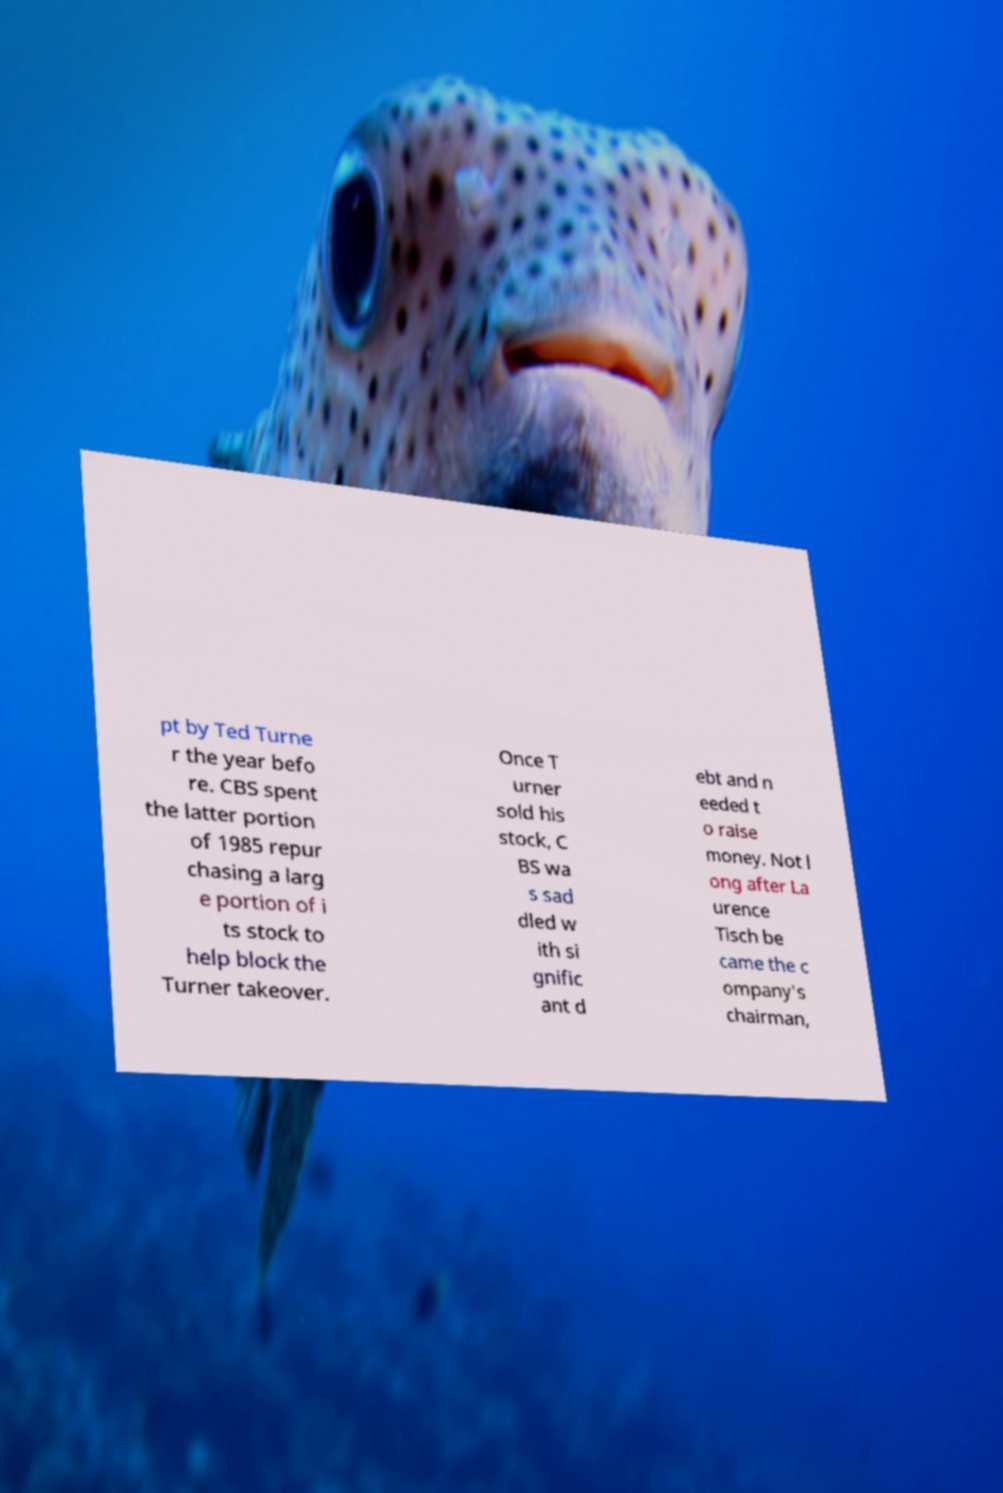Could you assist in decoding the text presented in this image and type it out clearly? pt by Ted Turne r the year befo re. CBS spent the latter portion of 1985 repur chasing a larg e portion of i ts stock to help block the Turner takeover. Once T urner sold his stock, C BS wa s sad dled w ith si gnific ant d ebt and n eeded t o raise money. Not l ong after La urence Tisch be came the c ompany's chairman, 